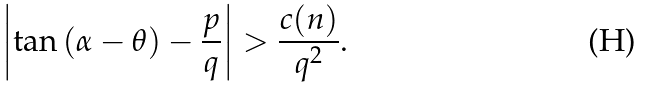Convert formula to latex. <formula><loc_0><loc_0><loc_500><loc_500>\left | \tan \left ( \alpha - \theta \right ) - \frac { p } { q } \right | > \frac { c ( n ) } { q ^ { 2 } } .</formula> 